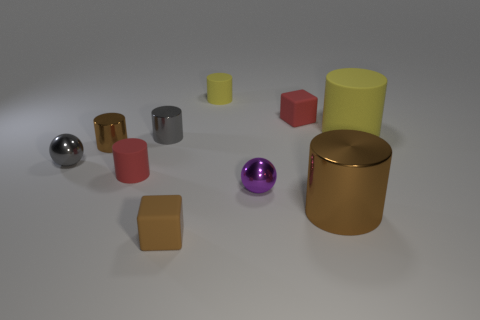Is the material of the gray cylinder the same as the tiny block that is in front of the large metal thing?
Provide a succinct answer. No. The red object that is left of the brown matte cube has what shape?
Offer a very short reply. Cylinder. What number of other objects are the same material as the gray ball?
Provide a succinct answer. 4. What number of other things are there of the same color as the large metal cylinder?
Ensure brevity in your answer.  2. The metallic thing that is both right of the gray metallic ball and left of the gray cylinder is what color?
Ensure brevity in your answer.  Brown. What number of big green cubes are there?
Give a very brief answer. 0. Does the brown block have the same material as the gray sphere?
Ensure brevity in your answer.  No. The yellow rubber thing that is left of the rubber cube that is on the right side of the cylinder that is behind the big yellow object is what shape?
Offer a very short reply. Cylinder. Are the red object to the right of the small yellow matte cylinder and the big object that is in front of the gray metal cylinder made of the same material?
Ensure brevity in your answer.  No. What material is the red cylinder?
Provide a succinct answer. Rubber. 